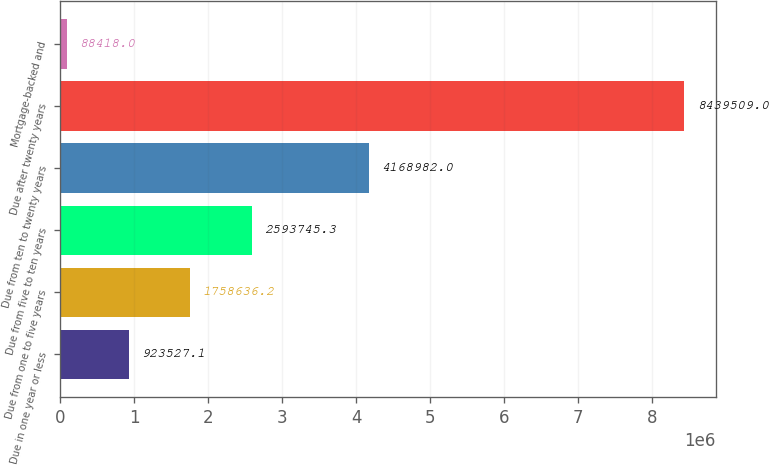Convert chart. <chart><loc_0><loc_0><loc_500><loc_500><bar_chart><fcel>Due in one year or less<fcel>Due from one to five years<fcel>Due from five to ten years<fcel>Due from ten to twenty years<fcel>Due after twenty years<fcel>Mortgage-backed and<nl><fcel>923527<fcel>1.75864e+06<fcel>2.59375e+06<fcel>4.16898e+06<fcel>8.43951e+06<fcel>88418<nl></chart> 